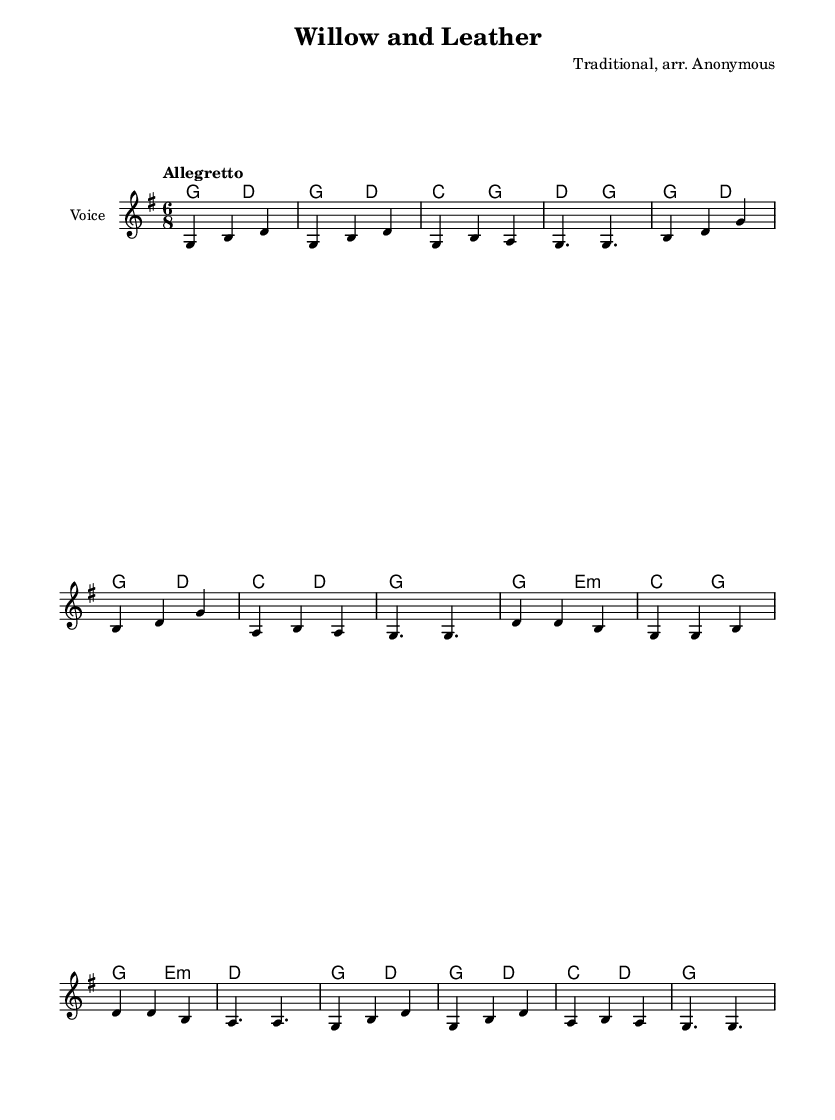What is the key signature of this music? The key signature is G major, which has one sharp (F#). This can be identified by looking at the key signature indicated at the beginning of the sheet music.
Answer: G major What is the time signature of this music? The time signature is 6/8, indicated at the beginning of the score under the key signature. This means there are six eighth notes in each measure.
Answer: 6/8 What is the tempo marking of this piece? The tempo marking is "Allegretto," which is typically understood to mean moderately fast. This is found in the tempo indication at the start of the score.
Answer: Allegretto How many measures are in the melody section? There are 12 measures in the melody section, which can be counted by analyzing the notes and bar lines throughout the melody part of the score.
Answer: 12 What is the ending chord for the piece? The ending chord is G major, which is represented at the end of the harmony section in the final chord of the score.
Answer: G major What do the lyrics in this song celebrate? The lyrics celebrate legendary cricket players and their achievements, as indicated by phrases referencing cricket heroes and their memories. This contextual understanding can be deducted from analyzing the themes presented in the lyrics.
Answer: Cricket heroes What instruments might typically play this piece? This piece is likely intended for voice and guitar or similar accompanying instruments, as indicated by the staff for vocals and the chord names provided above the melody lines for harmonic support.
Answer: Voice and guitar 